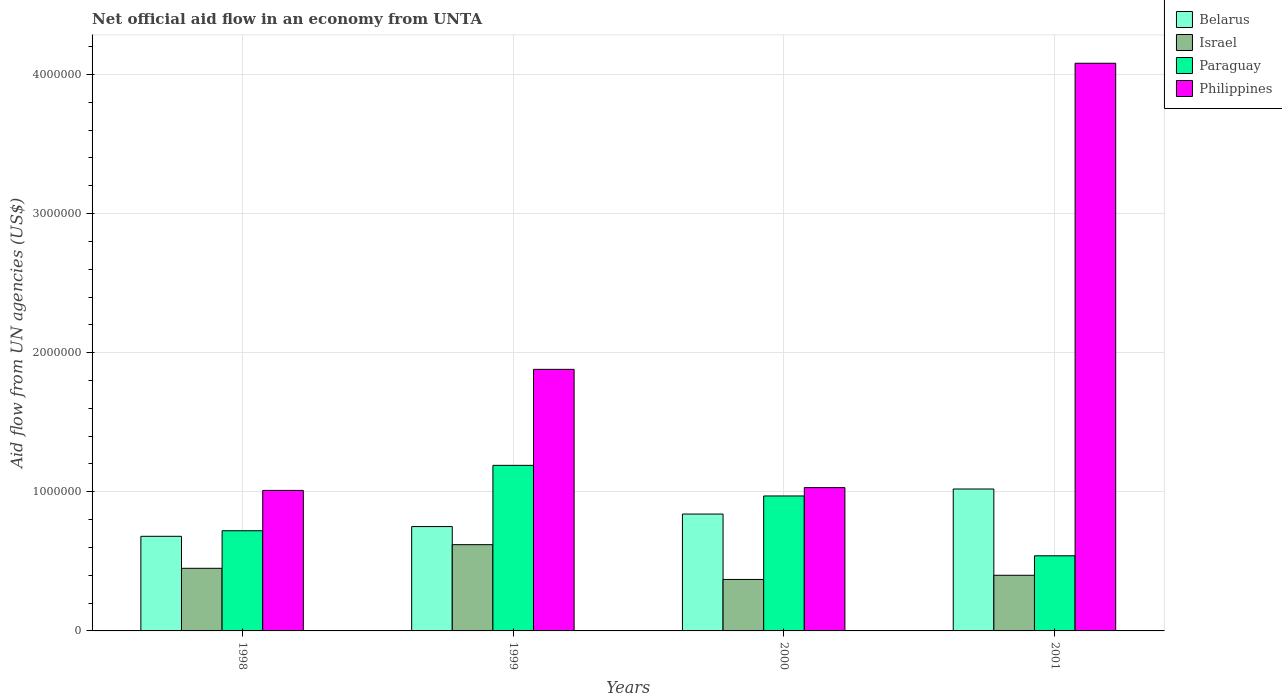How many different coloured bars are there?
Provide a succinct answer. 4. How many groups of bars are there?
Ensure brevity in your answer.  4. How many bars are there on the 1st tick from the left?
Give a very brief answer. 4. What is the label of the 3rd group of bars from the left?
Your answer should be very brief. 2000. What is the net official aid flow in Paraguay in 2000?
Ensure brevity in your answer.  9.70e+05. Across all years, what is the maximum net official aid flow in Israel?
Ensure brevity in your answer.  6.20e+05. Across all years, what is the minimum net official aid flow in Belarus?
Your answer should be very brief. 6.80e+05. In which year was the net official aid flow in Paraguay maximum?
Offer a terse response. 1999. What is the total net official aid flow in Israel in the graph?
Make the answer very short. 1.84e+06. What is the difference between the net official aid flow in Paraguay in 1999 and that in 2001?
Ensure brevity in your answer.  6.50e+05. In the year 2000, what is the difference between the net official aid flow in Philippines and net official aid flow in Israel?
Offer a terse response. 6.60e+05. In how many years, is the net official aid flow in Paraguay greater than 1200000 US$?
Offer a very short reply. 0. What is the ratio of the net official aid flow in Paraguay in 1998 to that in 1999?
Keep it short and to the point. 0.61. Is the difference between the net official aid flow in Philippines in 1998 and 2000 greater than the difference between the net official aid flow in Israel in 1998 and 2000?
Make the answer very short. No. What is the difference between the highest and the lowest net official aid flow in Paraguay?
Give a very brief answer. 6.50e+05. Is the sum of the net official aid flow in Philippines in 1999 and 2000 greater than the maximum net official aid flow in Israel across all years?
Offer a very short reply. Yes. What does the 1st bar from the left in 1998 represents?
Ensure brevity in your answer.  Belarus. What does the 2nd bar from the right in 1998 represents?
Offer a very short reply. Paraguay. How many bars are there?
Provide a short and direct response. 16. Are all the bars in the graph horizontal?
Your answer should be very brief. No. What is the difference between two consecutive major ticks on the Y-axis?
Keep it short and to the point. 1.00e+06. Are the values on the major ticks of Y-axis written in scientific E-notation?
Keep it short and to the point. No. Does the graph contain any zero values?
Make the answer very short. No. Where does the legend appear in the graph?
Ensure brevity in your answer.  Top right. How many legend labels are there?
Keep it short and to the point. 4. What is the title of the graph?
Your answer should be compact. Net official aid flow in an economy from UNTA. What is the label or title of the X-axis?
Offer a terse response. Years. What is the label or title of the Y-axis?
Give a very brief answer. Aid flow from UN agencies (US$). What is the Aid flow from UN agencies (US$) in Belarus in 1998?
Make the answer very short. 6.80e+05. What is the Aid flow from UN agencies (US$) in Paraguay in 1998?
Offer a terse response. 7.20e+05. What is the Aid flow from UN agencies (US$) in Philippines in 1998?
Give a very brief answer. 1.01e+06. What is the Aid flow from UN agencies (US$) in Belarus in 1999?
Your answer should be compact. 7.50e+05. What is the Aid flow from UN agencies (US$) of Israel in 1999?
Provide a succinct answer. 6.20e+05. What is the Aid flow from UN agencies (US$) of Paraguay in 1999?
Ensure brevity in your answer.  1.19e+06. What is the Aid flow from UN agencies (US$) of Philippines in 1999?
Make the answer very short. 1.88e+06. What is the Aid flow from UN agencies (US$) of Belarus in 2000?
Your answer should be very brief. 8.40e+05. What is the Aid flow from UN agencies (US$) of Paraguay in 2000?
Provide a succinct answer. 9.70e+05. What is the Aid flow from UN agencies (US$) of Philippines in 2000?
Offer a very short reply. 1.03e+06. What is the Aid flow from UN agencies (US$) in Belarus in 2001?
Ensure brevity in your answer.  1.02e+06. What is the Aid flow from UN agencies (US$) in Paraguay in 2001?
Offer a very short reply. 5.40e+05. What is the Aid flow from UN agencies (US$) in Philippines in 2001?
Your answer should be compact. 4.08e+06. Across all years, what is the maximum Aid flow from UN agencies (US$) in Belarus?
Your answer should be compact. 1.02e+06. Across all years, what is the maximum Aid flow from UN agencies (US$) of Israel?
Provide a short and direct response. 6.20e+05. Across all years, what is the maximum Aid flow from UN agencies (US$) of Paraguay?
Ensure brevity in your answer.  1.19e+06. Across all years, what is the maximum Aid flow from UN agencies (US$) in Philippines?
Provide a succinct answer. 4.08e+06. Across all years, what is the minimum Aid flow from UN agencies (US$) of Belarus?
Keep it short and to the point. 6.80e+05. Across all years, what is the minimum Aid flow from UN agencies (US$) in Israel?
Your answer should be very brief. 3.70e+05. Across all years, what is the minimum Aid flow from UN agencies (US$) in Paraguay?
Keep it short and to the point. 5.40e+05. Across all years, what is the minimum Aid flow from UN agencies (US$) of Philippines?
Give a very brief answer. 1.01e+06. What is the total Aid flow from UN agencies (US$) of Belarus in the graph?
Give a very brief answer. 3.29e+06. What is the total Aid flow from UN agencies (US$) in Israel in the graph?
Provide a short and direct response. 1.84e+06. What is the total Aid flow from UN agencies (US$) in Paraguay in the graph?
Your response must be concise. 3.42e+06. What is the difference between the Aid flow from UN agencies (US$) of Belarus in 1998 and that in 1999?
Offer a very short reply. -7.00e+04. What is the difference between the Aid flow from UN agencies (US$) in Paraguay in 1998 and that in 1999?
Your answer should be compact. -4.70e+05. What is the difference between the Aid flow from UN agencies (US$) in Philippines in 1998 and that in 1999?
Your answer should be very brief. -8.70e+05. What is the difference between the Aid flow from UN agencies (US$) in Belarus in 1998 and that in 2000?
Make the answer very short. -1.60e+05. What is the difference between the Aid flow from UN agencies (US$) of Paraguay in 1998 and that in 2000?
Keep it short and to the point. -2.50e+05. What is the difference between the Aid flow from UN agencies (US$) in Belarus in 1998 and that in 2001?
Your answer should be very brief. -3.40e+05. What is the difference between the Aid flow from UN agencies (US$) in Paraguay in 1998 and that in 2001?
Provide a short and direct response. 1.80e+05. What is the difference between the Aid flow from UN agencies (US$) of Philippines in 1998 and that in 2001?
Offer a terse response. -3.07e+06. What is the difference between the Aid flow from UN agencies (US$) of Israel in 1999 and that in 2000?
Your answer should be compact. 2.50e+05. What is the difference between the Aid flow from UN agencies (US$) of Paraguay in 1999 and that in 2000?
Your answer should be compact. 2.20e+05. What is the difference between the Aid flow from UN agencies (US$) in Philippines in 1999 and that in 2000?
Offer a very short reply. 8.50e+05. What is the difference between the Aid flow from UN agencies (US$) in Belarus in 1999 and that in 2001?
Offer a terse response. -2.70e+05. What is the difference between the Aid flow from UN agencies (US$) in Paraguay in 1999 and that in 2001?
Your answer should be compact. 6.50e+05. What is the difference between the Aid flow from UN agencies (US$) of Philippines in 1999 and that in 2001?
Ensure brevity in your answer.  -2.20e+06. What is the difference between the Aid flow from UN agencies (US$) of Belarus in 2000 and that in 2001?
Provide a short and direct response. -1.80e+05. What is the difference between the Aid flow from UN agencies (US$) of Paraguay in 2000 and that in 2001?
Provide a short and direct response. 4.30e+05. What is the difference between the Aid flow from UN agencies (US$) of Philippines in 2000 and that in 2001?
Your answer should be very brief. -3.05e+06. What is the difference between the Aid flow from UN agencies (US$) in Belarus in 1998 and the Aid flow from UN agencies (US$) in Israel in 1999?
Offer a very short reply. 6.00e+04. What is the difference between the Aid flow from UN agencies (US$) in Belarus in 1998 and the Aid flow from UN agencies (US$) in Paraguay in 1999?
Keep it short and to the point. -5.10e+05. What is the difference between the Aid flow from UN agencies (US$) in Belarus in 1998 and the Aid flow from UN agencies (US$) in Philippines in 1999?
Offer a very short reply. -1.20e+06. What is the difference between the Aid flow from UN agencies (US$) in Israel in 1998 and the Aid flow from UN agencies (US$) in Paraguay in 1999?
Provide a succinct answer. -7.40e+05. What is the difference between the Aid flow from UN agencies (US$) of Israel in 1998 and the Aid flow from UN agencies (US$) of Philippines in 1999?
Make the answer very short. -1.43e+06. What is the difference between the Aid flow from UN agencies (US$) of Paraguay in 1998 and the Aid flow from UN agencies (US$) of Philippines in 1999?
Your answer should be very brief. -1.16e+06. What is the difference between the Aid flow from UN agencies (US$) of Belarus in 1998 and the Aid flow from UN agencies (US$) of Paraguay in 2000?
Make the answer very short. -2.90e+05. What is the difference between the Aid flow from UN agencies (US$) in Belarus in 1998 and the Aid flow from UN agencies (US$) in Philippines in 2000?
Ensure brevity in your answer.  -3.50e+05. What is the difference between the Aid flow from UN agencies (US$) in Israel in 1998 and the Aid flow from UN agencies (US$) in Paraguay in 2000?
Give a very brief answer. -5.20e+05. What is the difference between the Aid flow from UN agencies (US$) in Israel in 1998 and the Aid flow from UN agencies (US$) in Philippines in 2000?
Provide a succinct answer. -5.80e+05. What is the difference between the Aid flow from UN agencies (US$) in Paraguay in 1998 and the Aid flow from UN agencies (US$) in Philippines in 2000?
Your answer should be compact. -3.10e+05. What is the difference between the Aid flow from UN agencies (US$) of Belarus in 1998 and the Aid flow from UN agencies (US$) of Philippines in 2001?
Provide a short and direct response. -3.40e+06. What is the difference between the Aid flow from UN agencies (US$) of Israel in 1998 and the Aid flow from UN agencies (US$) of Paraguay in 2001?
Keep it short and to the point. -9.00e+04. What is the difference between the Aid flow from UN agencies (US$) of Israel in 1998 and the Aid flow from UN agencies (US$) of Philippines in 2001?
Keep it short and to the point. -3.63e+06. What is the difference between the Aid flow from UN agencies (US$) of Paraguay in 1998 and the Aid flow from UN agencies (US$) of Philippines in 2001?
Provide a short and direct response. -3.36e+06. What is the difference between the Aid flow from UN agencies (US$) in Belarus in 1999 and the Aid flow from UN agencies (US$) in Philippines in 2000?
Your answer should be compact. -2.80e+05. What is the difference between the Aid flow from UN agencies (US$) of Israel in 1999 and the Aid flow from UN agencies (US$) of Paraguay in 2000?
Ensure brevity in your answer.  -3.50e+05. What is the difference between the Aid flow from UN agencies (US$) in Israel in 1999 and the Aid flow from UN agencies (US$) in Philippines in 2000?
Keep it short and to the point. -4.10e+05. What is the difference between the Aid flow from UN agencies (US$) of Paraguay in 1999 and the Aid flow from UN agencies (US$) of Philippines in 2000?
Offer a terse response. 1.60e+05. What is the difference between the Aid flow from UN agencies (US$) of Belarus in 1999 and the Aid flow from UN agencies (US$) of Philippines in 2001?
Provide a short and direct response. -3.33e+06. What is the difference between the Aid flow from UN agencies (US$) of Israel in 1999 and the Aid flow from UN agencies (US$) of Paraguay in 2001?
Offer a terse response. 8.00e+04. What is the difference between the Aid flow from UN agencies (US$) in Israel in 1999 and the Aid flow from UN agencies (US$) in Philippines in 2001?
Your answer should be very brief. -3.46e+06. What is the difference between the Aid flow from UN agencies (US$) in Paraguay in 1999 and the Aid flow from UN agencies (US$) in Philippines in 2001?
Offer a very short reply. -2.89e+06. What is the difference between the Aid flow from UN agencies (US$) in Belarus in 2000 and the Aid flow from UN agencies (US$) in Israel in 2001?
Give a very brief answer. 4.40e+05. What is the difference between the Aid flow from UN agencies (US$) of Belarus in 2000 and the Aid flow from UN agencies (US$) of Paraguay in 2001?
Keep it short and to the point. 3.00e+05. What is the difference between the Aid flow from UN agencies (US$) of Belarus in 2000 and the Aid flow from UN agencies (US$) of Philippines in 2001?
Provide a short and direct response. -3.24e+06. What is the difference between the Aid flow from UN agencies (US$) of Israel in 2000 and the Aid flow from UN agencies (US$) of Paraguay in 2001?
Ensure brevity in your answer.  -1.70e+05. What is the difference between the Aid flow from UN agencies (US$) in Israel in 2000 and the Aid flow from UN agencies (US$) in Philippines in 2001?
Keep it short and to the point. -3.71e+06. What is the difference between the Aid flow from UN agencies (US$) of Paraguay in 2000 and the Aid flow from UN agencies (US$) of Philippines in 2001?
Your answer should be very brief. -3.11e+06. What is the average Aid flow from UN agencies (US$) in Belarus per year?
Offer a very short reply. 8.22e+05. What is the average Aid flow from UN agencies (US$) in Paraguay per year?
Ensure brevity in your answer.  8.55e+05. What is the average Aid flow from UN agencies (US$) of Philippines per year?
Give a very brief answer. 2.00e+06. In the year 1998, what is the difference between the Aid flow from UN agencies (US$) in Belarus and Aid flow from UN agencies (US$) in Israel?
Keep it short and to the point. 2.30e+05. In the year 1998, what is the difference between the Aid flow from UN agencies (US$) in Belarus and Aid flow from UN agencies (US$) in Philippines?
Provide a short and direct response. -3.30e+05. In the year 1998, what is the difference between the Aid flow from UN agencies (US$) in Israel and Aid flow from UN agencies (US$) in Paraguay?
Offer a terse response. -2.70e+05. In the year 1998, what is the difference between the Aid flow from UN agencies (US$) of Israel and Aid flow from UN agencies (US$) of Philippines?
Make the answer very short. -5.60e+05. In the year 1998, what is the difference between the Aid flow from UN agencies (US$) in Paraguay and Aid flow from UN agencies (US$) in Philippines?
Provide a short and direct response. -2.90e+05. In the year 1999, what is the difference between the Aid flow from UN agencies (US$) in Belarus and Aid flow from UN agencies (US$) in Paraguay?
Your answer should be very brief. -4.40e+05. In the year 1999, what is the difference between the Aid flow from UN agencies (US$) of Belarus and Aid flow from UN agencies (US$) of Philippines?
Your answer should be compact. -1.13e+06. In the year 1999, what is the difference between the Aid flow from UN agencies (US$) of Israel and Aid flow from UN agencies (US$) of Paraguay?
Your answer should be very brief. -5.70e+05. In the year 1999, what is the difference between the Aid flow from UN agencies (US$) in Israel and Aid flow from UN agencies (US$) in Philippines?
Your answer should be very brief. -1.26e+06. In the year 1999, what is the difference between the Aid flow from UN agencies (US$) in Paraguay and Aid flow from UN agencies (US$) in Philippines?
Offer a terse response. -6.90e+05. In the year 2000, what is the difference between the Aid flow from UN agencies (US$) of Belarus and Aid flow from UN agencies (US$) of Israel?
Offer a terse response. 4.70e+05. In the year 2000, what is the difference between the Aid flow from UN agencies (US$) of Belarus and Aid flow from UN agencies (US$) of Paraguay?
Your response must be concise. -1.30e+05. In the year 2000, what is the difference between the Aid flow from UN agencies (US$) of Israel and Aid flow from UN agencies (US$) of Paraguay?
Ensure brevity in your answer.  -6.00e+05. In the year 2000, what is the difference between the Aid flow from UN agencies (US$) in Israel and Aid flow from UN agencies (US$) in Philippines?
Keep it short and to the point. -6.60e+05. In the year 2001, what is the difference between the Aid flow from UN agencies (US$) in Belarus and Aid flow from UN agencies (US$) in Israel?
Give a very brief answer. 6.20e+05. In the year 2001, what is the difference between the Aid flow from UN agencies (US$) in Belarus and Aid flow from UN agencies (US$) in Philippines?
Offer a very short reply. -3.06e+06. In the year 2001, what is the difference between the Aid flow from UN agencies (US$) of Israel and Aid flow from UN agencies (US$) of Philippines?
Your response must be concise. -3.68e+06. In the year 2001, what is the difference between the Aid flow from UN agencies (US$) of Paraguay and Aid flow from UN agencies (US$) of Philippines?
Your answer should be compact. -3.54e+06. What is the ratio of the Aid flow from UN agencies (US$) in Belarus in 1998 to that in 1999?
Your response must be concise. 0.91. What is the ratio of the Aid flow from UN agencies (US$) of Israel in 1998 to that in 1999?
Give a very brief answer. 0.73. What is the ratio of the Aid flow from UN agencies (US$) of Paraguay in 1998 to that in 1999?
Make the answer very short. 0.6. What is the ratio of the Aid flow from UN agencies (US$) in Philippines in 1998 to that in 1999?
Your answer should be compact. 0.54. What is the ratio of the Aid flow from UN agencies (US$) of Belarus in 1998 to that in 2000?
Your answer should be compact. 0.81. What is the ratio of the Aid flow from UN agencies (US$) of Israel in 1998 to that in 2000?
Your response must be concise. 1.22. What is the ratio of the Aid flow from UN agencies (US$) of Paraguay in 1998 to that in 2000?
Your answer should be compact. 0.74. What is the ratio of the Aid flow from UN agencies (US$) in Philippines in 1998 to that in 2000?
Keep it short and to the point. 0.98. What is the ratio of the Aid flow from UN agencies (US$) of Philippines in 1998 to that in 2001?
Your answer should be compact. 0.25. What is the ratio of the Aid flow from UN agencies (US$) in Belarus in 1999 to that in 2000?
Give a very brief answer. 0.89. What is the ratio of the Aid flow from UN agencies (US$) in Israel in 1999 to that in 2000?
Offer a very short reply. 1.68. What is the ratio of the Aid flow from UN agencies (US$) in Paraguay in 1999 to that in 2000?
Your response must be concise. 1.23. What is the ratio of the Aid flow from UN agencies (US$) of Philippines in 1999 to that in 2000?
Offer a very short reply. 1.83. What is the ratio of the Aid flow from UN agencies (US$) of Belarus in 1999 to that in 2001?
Your response must be concise. 0.74. What is the ratio of the Aid flow from UN agencies (US$) in Israel in 1999 to that in 2001?
Provide a short and direct response. 1.55. What is the ratio of the Aid flow from UN agencies (US$) in Paraguay in 1999 to that in 2001?
Make the answer very short. 2.2. What is the ratio of the Aid flow from UN agencies (US$) of Philippines in 1999 to that in 2001?
Keep it short and to the point. 0.46. What is the ratio of the Aid flow from UN agencies (US$) of Belarus in 2000 to that in 2001?
Offer a terse response. 0.82. What is the ratio of the Aid flow from UN agencies (US$) in Israel in 2000 to that in 2001?
Provide a short and direct response. 0.93. What is the ratio of the Aid flow from UN agencies (US$) in Paraguay in 2000 to that in 2001?
Keep it short and to the point. 1.8. What is the ratio of the Aid flow from UN agencies (US$) of Philippines in 2000 to that in 2001?
Offer a very short reply. 0.25. What is the difference between the highest and the second highest Aid flow from UN agencies (US$) in Israel?
Make the answer very short. 1.70e+05. What is the difference between the highest and the second highest Aid flow from UN agencies (US$) in Paraguay?
Give a very brief answer. 2.20e+05. What is the difference between the highest and the second highest Aid flow from UN agencies (US$) of Philippines?
Your answer should be compact. 2.20e+06. What is the difference between the highest and the lowest Aid flow from UN agencies (US$) of Belarus?
Offer a terse response. 3.40e+05. What is the difference between the highest and the lowest Aid flow from UN agencies (US$) of Paraguay?
Provide a short and direct response. 6.50e+05. What is the difference between the highest and the lowest Aid flow from UN agencies (US$) of Philippines?
Your answer should be very brief. 3.07e+06. 